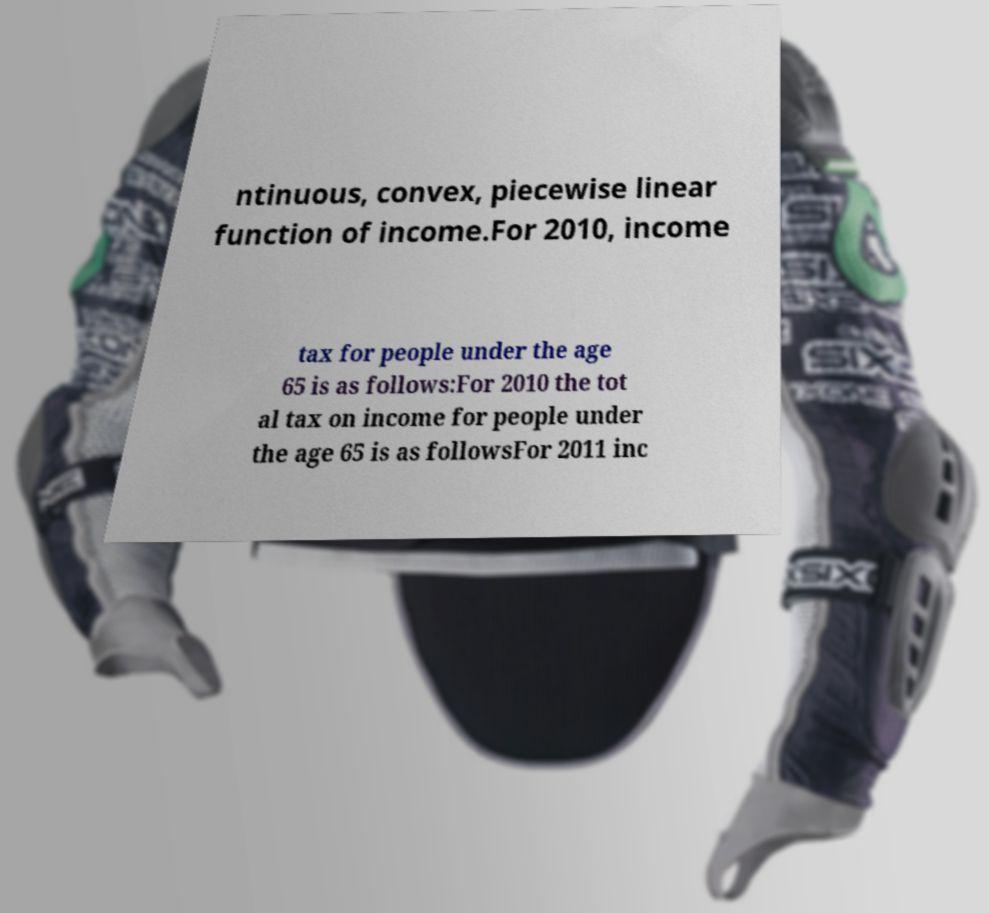Please identify and transcribe the text found in this image. ntinuous, convex, piecewise linear function of income.For 2010, income tax for people under the age 65 is as follows:For 2010 the tot al tax on income for people under the age 65 is as followsFor 2011 inc 